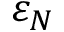Convert formula to latex. <formula><loc_0><loc_0><loc_500><loc_500>\varepsilon _ { N }</formula> 